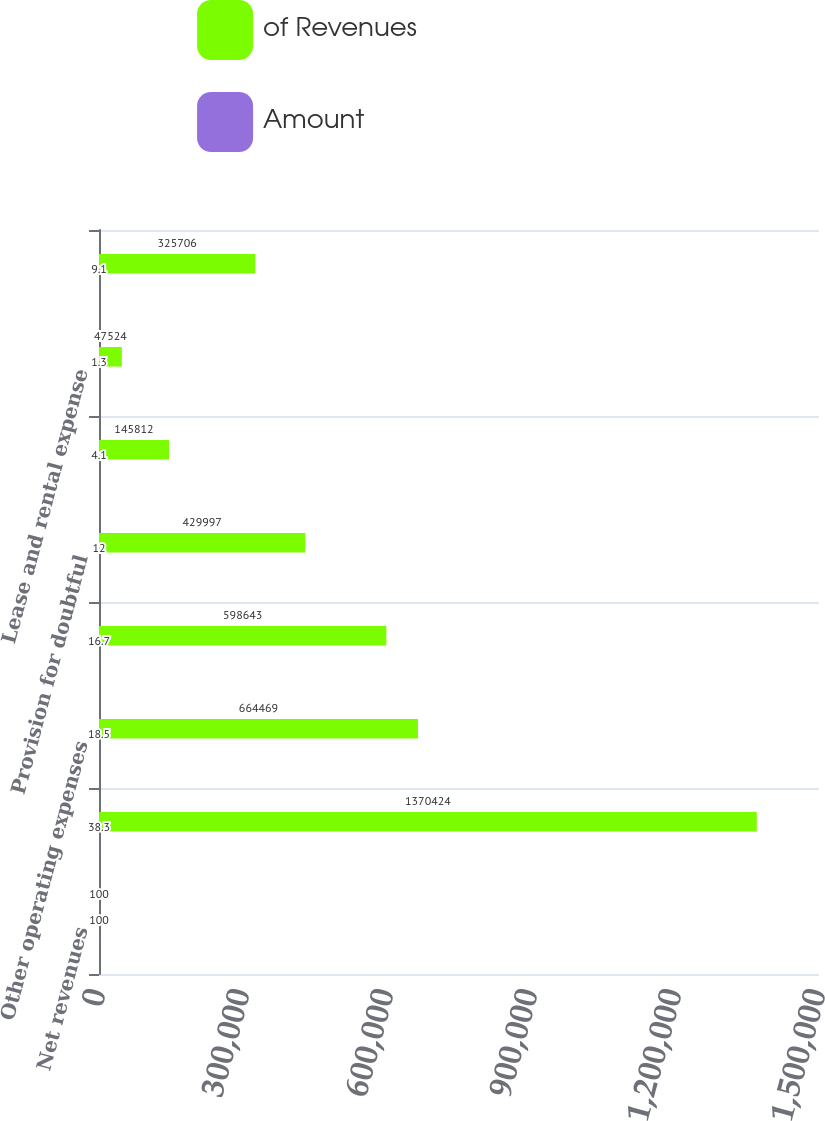Convert chart to OTSL. <chart><loc_0><loc_0><loc_500><loc_500><stacked_bar_chart><ecel><fcel>Net revenues<fcel>Salaries wages and benefits<fcel>Other operating expenses<fcel>Supplies expense<fcel>Provision for doubtful<fcel>Depreciation and amortization<fcel>Lease and rental expense<fcel>Income before interest expense<nl><fcel>of Revenues<fcel>100<fcel>1.37042e+06<fcel>664469<fcel>598643<fcel>429997<fcel>145812<fcel>47524<fcel>325706<nl><fcel>Amount<fcel>100<fcel>38.3<fcel>18.5<fcel>16.7<fcel>12<fcel>4.1<fcel>1.3<fcel>9.1<nl></chart> 